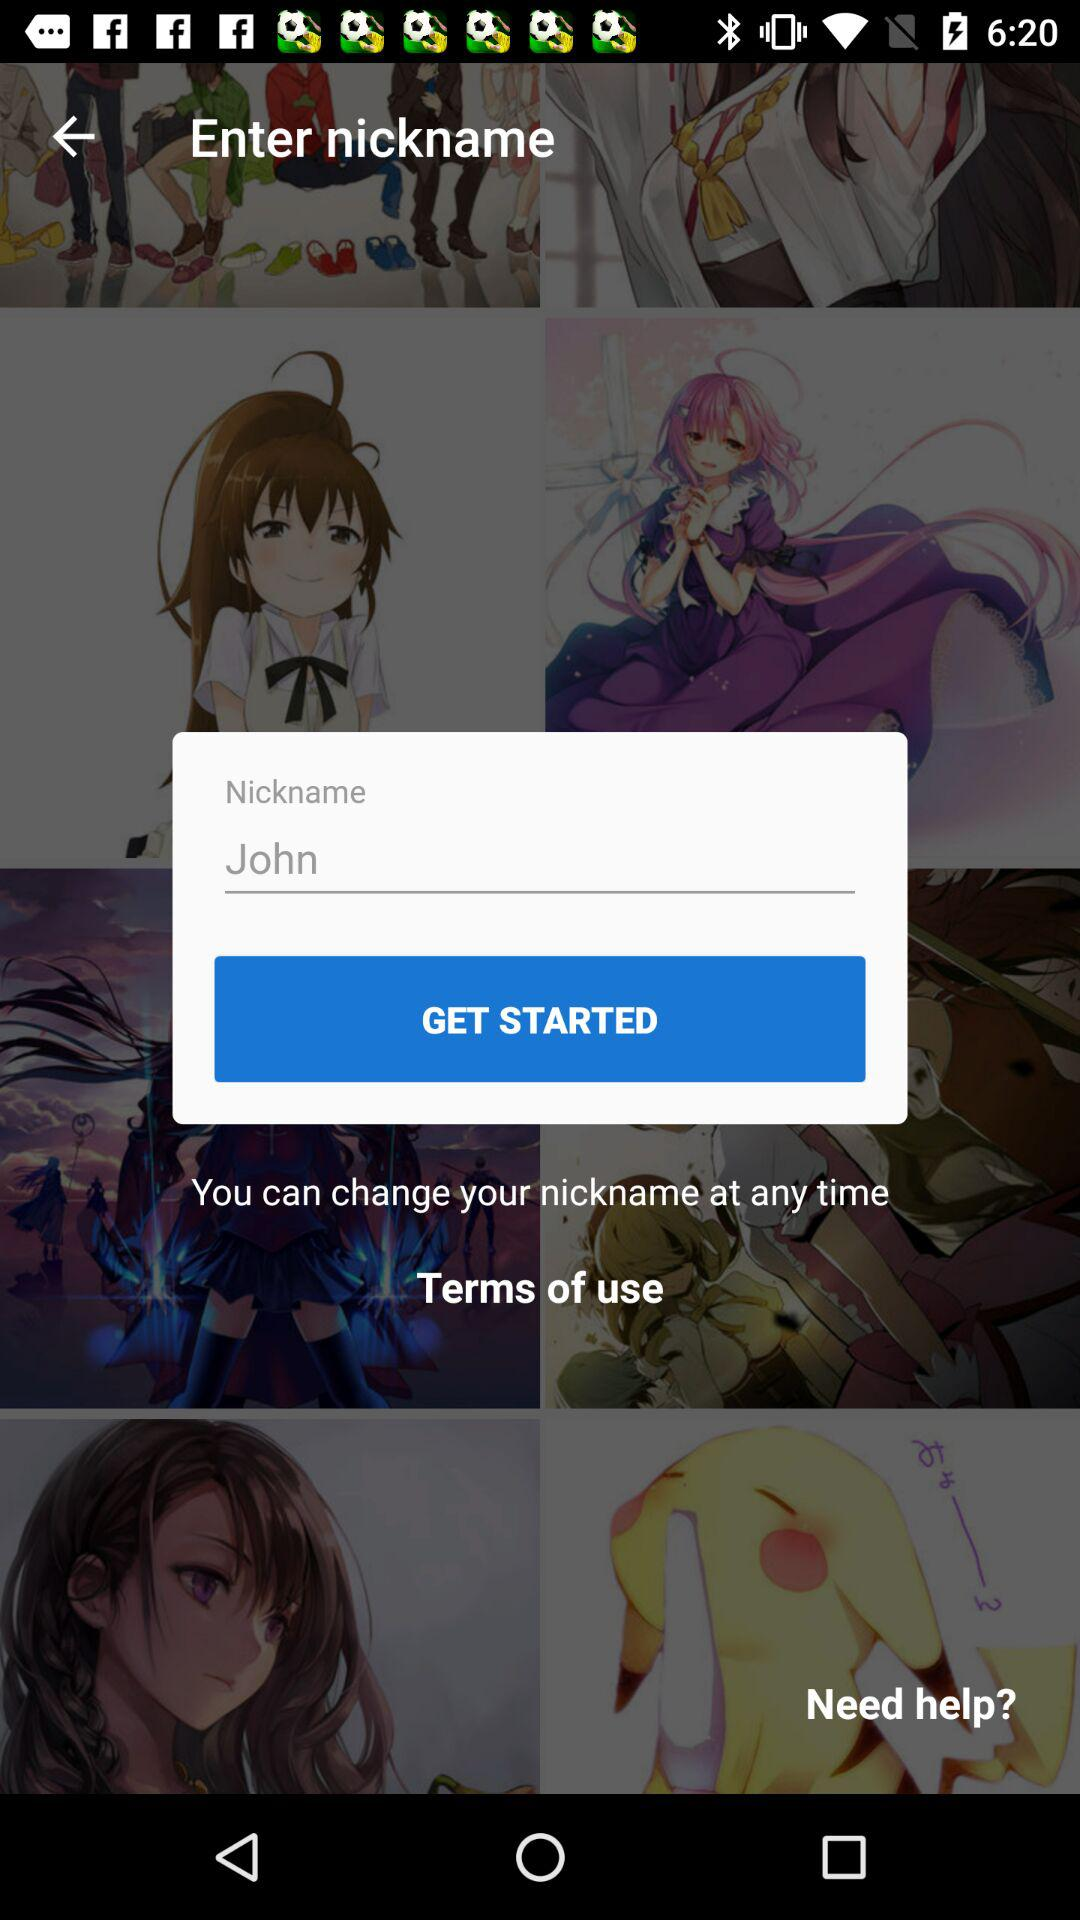What is the mentioned nickname? The mentioned nickname is John. 